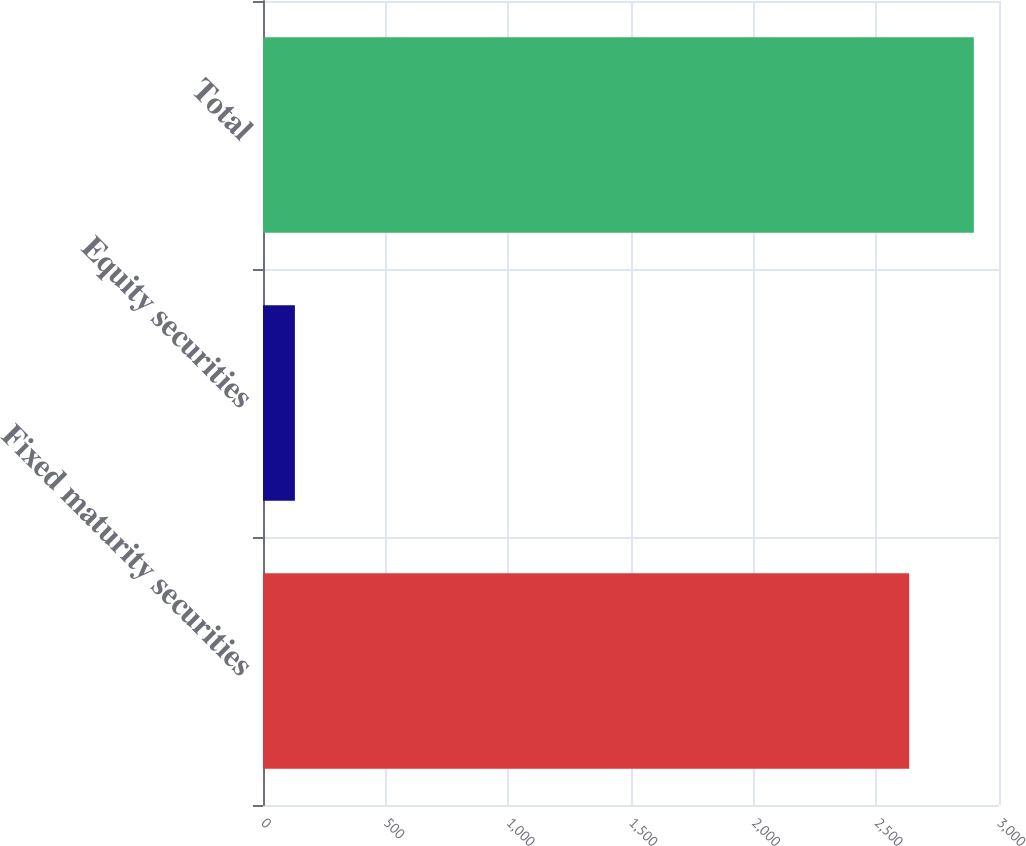Convert chart to OTSL. <chart><loc_0><loc_0><loc_500><loc_500><bar_chart><fcel>Fixed maturity securities<fcel>Equity securities<fcel>Total<nl><fcel>2634<fcel>130<fcel>2897.4<nl></chart> 